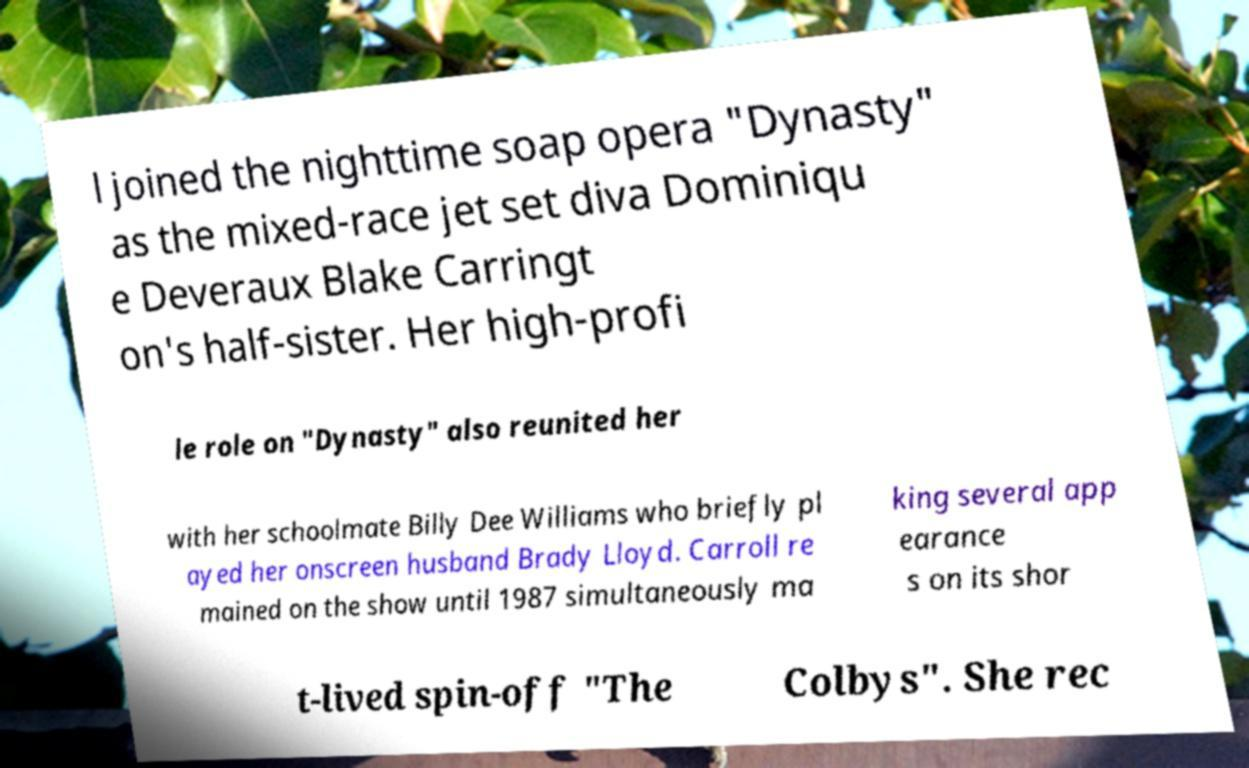Please identify and transcribe the text found in this image. l joined the nighttime soap opera "Dynasty" as the mixed-race jet set diva Dominiqu e Deveraux Blake Carringt on's half-sister. Her high-profi le role on "Dynasty" also reunited her with her schoolmate Billy Dee Williams who briefly pl ayed her onscreen husband Brady Lloyd. Carroll re mained on the show until 1987 simultaneously ma king several app earance s on its shor t-lived spin-off "The Colbys". She rec 